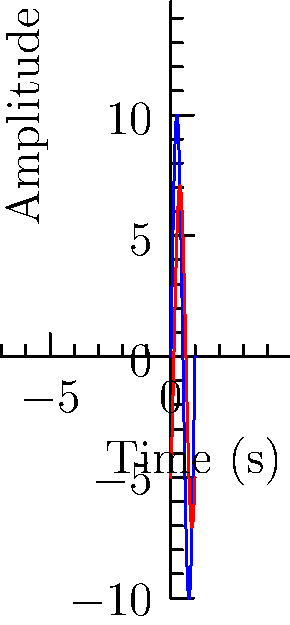In an RLC circuit, the voltage across the circuit is given by $v(t) = 10\sin(2\pi t)$ volts, and the current through the circuit is $i(t) = 7.07\sin(2\pi t - \frac{\pi}{4})$ amperes. What is the power factor of this circuit? To find the power factor, we need to follow these steps:

1) The power factor is defined as $\cos\phi$, where $\phi$ is the phase difference between voltage and current.

2) From the given equations:
   $v(t) = 10\sin(2\pi t)$
   $i(t) = 7.07\sin(2\pi t - \frac{\pi}{4})$

3) We can see that the current lags behind the voltage by $\frac{\pi}{4}$ radians or 45°.

4) Therefore, $\phi = \frac{\pi}{4}$

5) The power factor is:
   $PF = \cos\phi = \cos(\frac{\pi}{4})$

6) We know that $\cos(\frac{\pi}{4}) = \frac{\sqrt{2}}{2} \approx 0.707$

Thus, the power factor of this circuit is $\frac{\sqrt{2}}{2}$ or approximately 0.707.
Answer: $\frac{\sqrt{2}}{2}$ or 0.707 